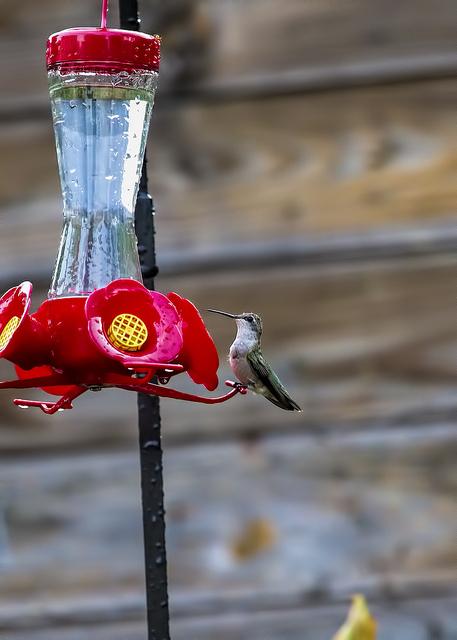Is the hummingbird flying?
Answer briefly. No. How many birds are in the picture?
Quick response, please. 1. What type of bird feeder is this?
Be succinct. Hummingbird. Are there real flowers in this picture?
Keep it brief. No. 